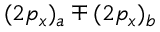<formula> <loc_0><loc_0><loc_500><loc_500>( 2 p _ { x } ) _ { a } \mp ( 2 p _ { x } ) _ { b }</formula> 